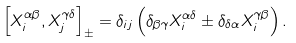Convert formula to latex. <formula><loc_0><loc_0><loc_500><loc_500>\left [ X _ { i } ^ { \alpha \beta } , X _ { j } ^ { \gamma \delta } \right ] _ { \pm } = \delta _ { i j } \left ( \delta _ { \beta \gamma } X _ { i } ^ { \alpha \delta } \pm \delta _ { \delta \alpha } X _ { i } ^ { \gamma \beta } \right ) .</formula> 